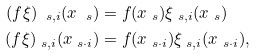<formula> <loc_0><loc_0><loc_500><loc_500>( f \xi ) _ { \ s , i } ( x _ { \ s } ) & = f ( x _ { \ s } ) \xi _ { \ s , i } ( x _ { \ s } ) \\ ( f \xi ) _ { \ s , i } ( x _ { \ s \cdot i } ) & = f ( x _ { \ s \cdot i } ) \xi _ { \ s , i } ( x _ { \ s \cdot i } ) ,</formula> 